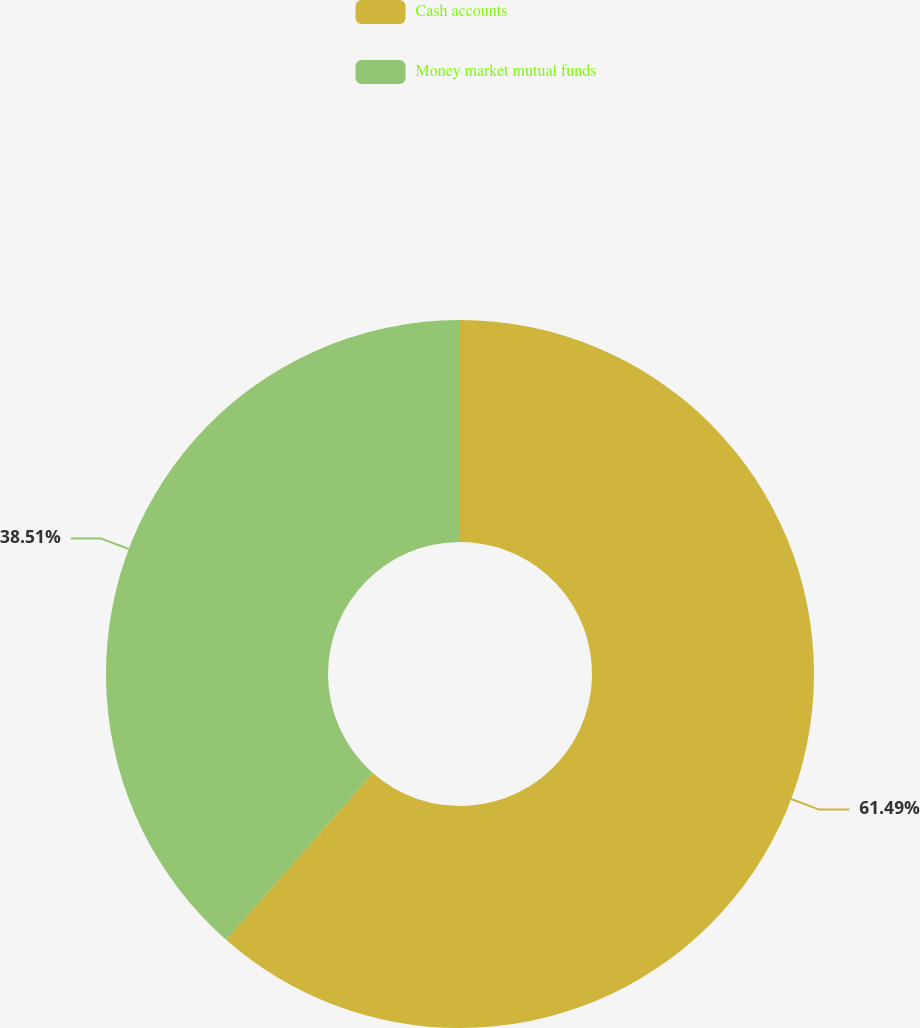Convert chart to OTSL. <chart><loc_0><loc_0><loc_500><loc_500><pie_chart><fcel>Cash accounts<fcel>Money market mutual funds<nl><fcel>61.49%<fcel>38.51%<nl></chart> 